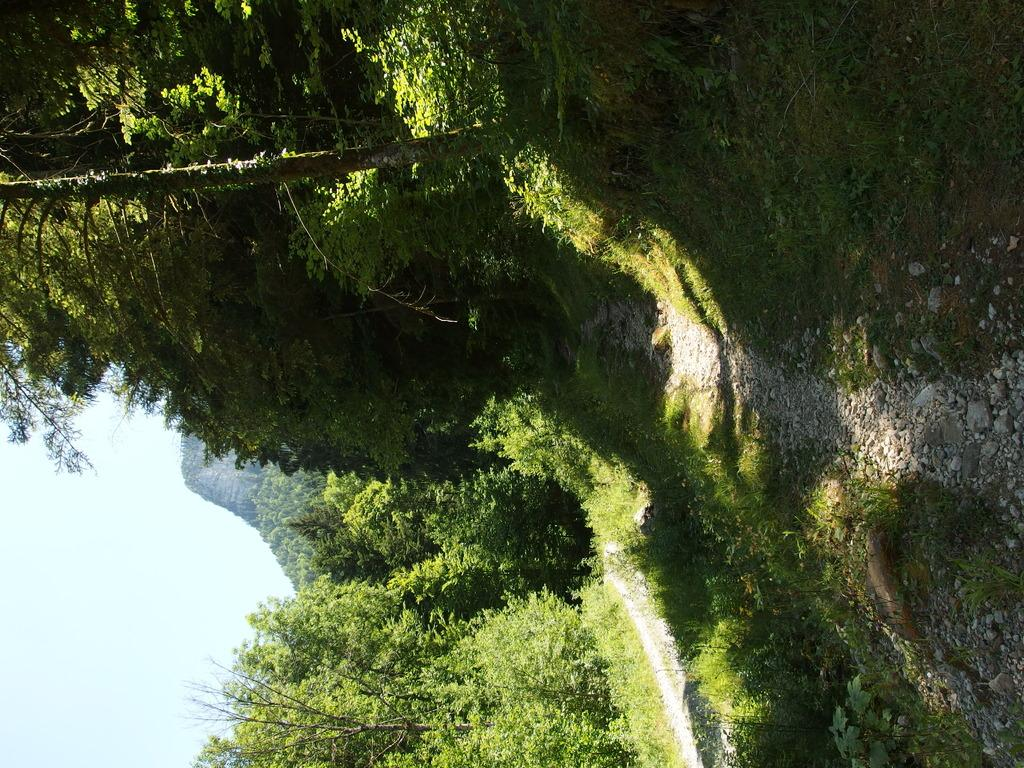What can be seen in the background of the image? There is a sky in the image. What type of vegetation is present in the image? There are plants, trees, and grass in the image. What other objects can be seen in the image? There are stones in the image. Can you see any scissors cutting the feather in the image? There are no scissors or feathers present in the image. 